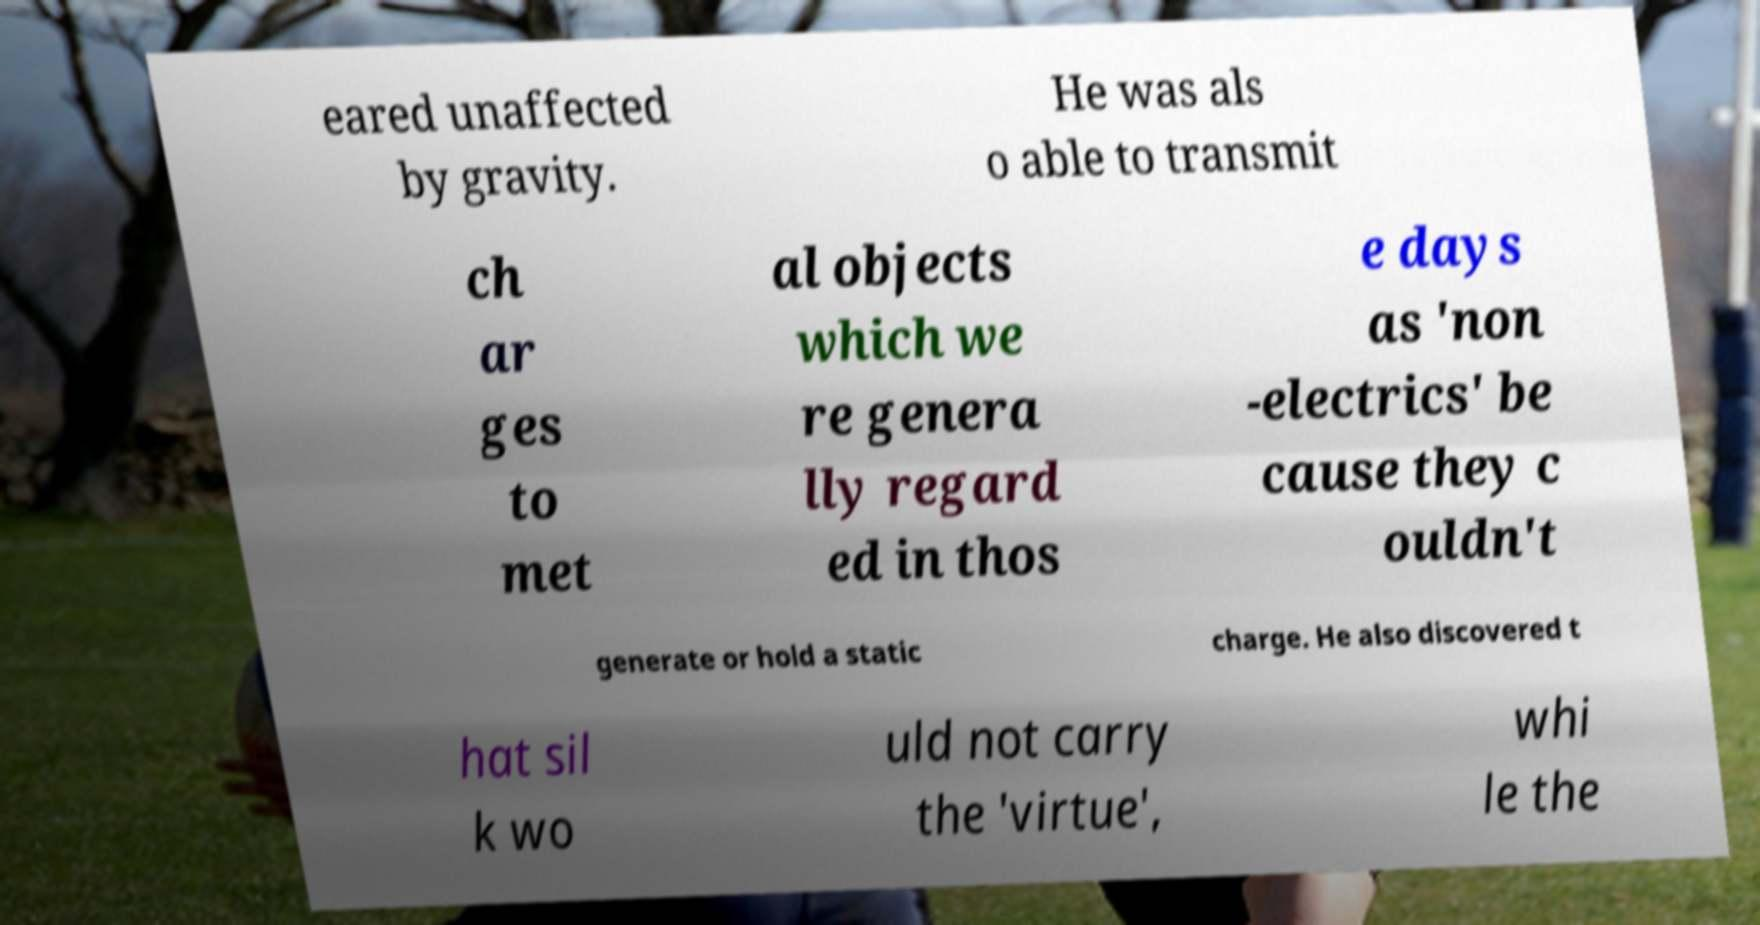Can you accurately transcribe the text from the provided image for me? eared unaffected by gravity. He was als o able to transmit ch ar ges to met al objects which we re genera lly regard ed in thos e days as 'non -electrics' be cause they c ouldn't generate or hold a static charge. He also discovered t hat sil k wo uld not carry the 'virtue', whi le the 